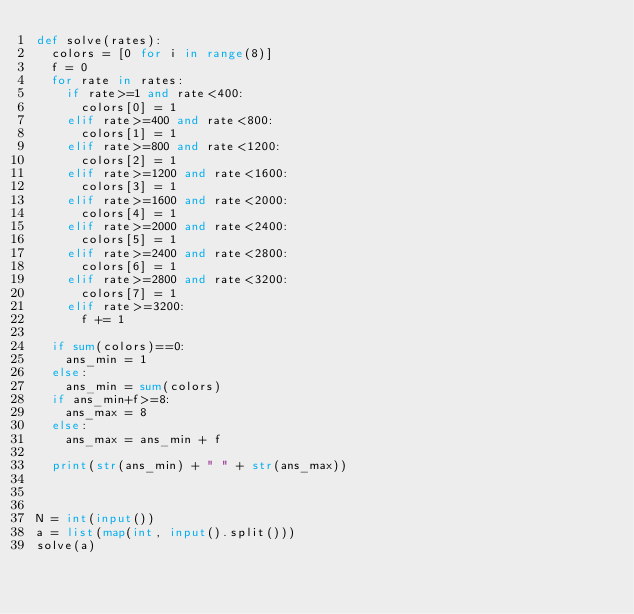<code> <loc_0><loc_0><loc_500><loc_500><_Python_>def solve(rates):
	colors = [0 for i in range(8)]
	f = 0
	for rate in rates:
		if rate>=1 and rate<400:
			colors[0] = 1
		elif rate>=400 and rate<800:
			colors[1] = 1
		elif rate>=800 and rate<1200:
			colors[2] = 1
		elif rate>=1200 and rate<1600:
			colors[3] = 1
		elif rate>=1600 and rate<2000:
			colors[4] = 1
		elif rate>=2000 and rate<2400:
			colors[5] = 1
		elif rate>=2400 and rate<2800:
			colors[6] = 1
		elif rate>=2800 and rate<3200:
			colors[7] = 1
		elif rate>=3200:
			f += 1

	if sum(colors)==0:
		ans_min = 1
	else:
		ans_min = sum(colors)
	if ans_min+f>=8:
		ans_max = 8
	else:
		ans_max = ans_min + f

	print(str(ans_min) + " " + str(ans_max))

		

N = int(input())
a = list(map(int, input().split()))
solve(a)</code> 